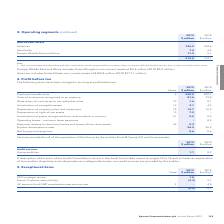According to Spirent Communications Plc's financial document, What have the items in the table been charged in arriving at? According to the financial document, profit before tax. The relevant text states: "4. Profit before tax The following items have been charged in arriving at profit before tax:..." Also, What was the amount of employee benefit costs in 2019? According to the financial document, 220.5 (in millions). The relevant text states: "Employee benefit costs 8 220.5 208.9..." Also, For which years were the items that have been charged in arriving at profit before tax recorded in? The document shows two values: 2019 and 2018. From the document: "133 Spirent Communications plc Annual Report 2019 2018 $ million..." Additionally, In which year was the amount of product development costs larger? According to the financial document, 2018. The relevant text states: "2018 $ million..." Also, can you calculate: What was the change in employee benefit costs? Based on the calculation: 220.5-208.9, the result is 11.6 (in millions). This is based on the information: "Employee benefit costs 8 220.5 208.9 Employee benefit costs 8 220.5 208.9..." The key data points involved are: 208.9, 220.5. Also, can you calculate: What was the percentage change in employee benefit costs? To answer this question, I need to perform calculations using the financial data. The calculation is: (220.5-208.9)/208.9, which equals 5.55 (percentage). This is based on the information: "Employee benefit costs 8 220.5 208.9 Employee benefit costs 8 220.5 208.9..." The key data points involved are: 208.9, 220.5. 